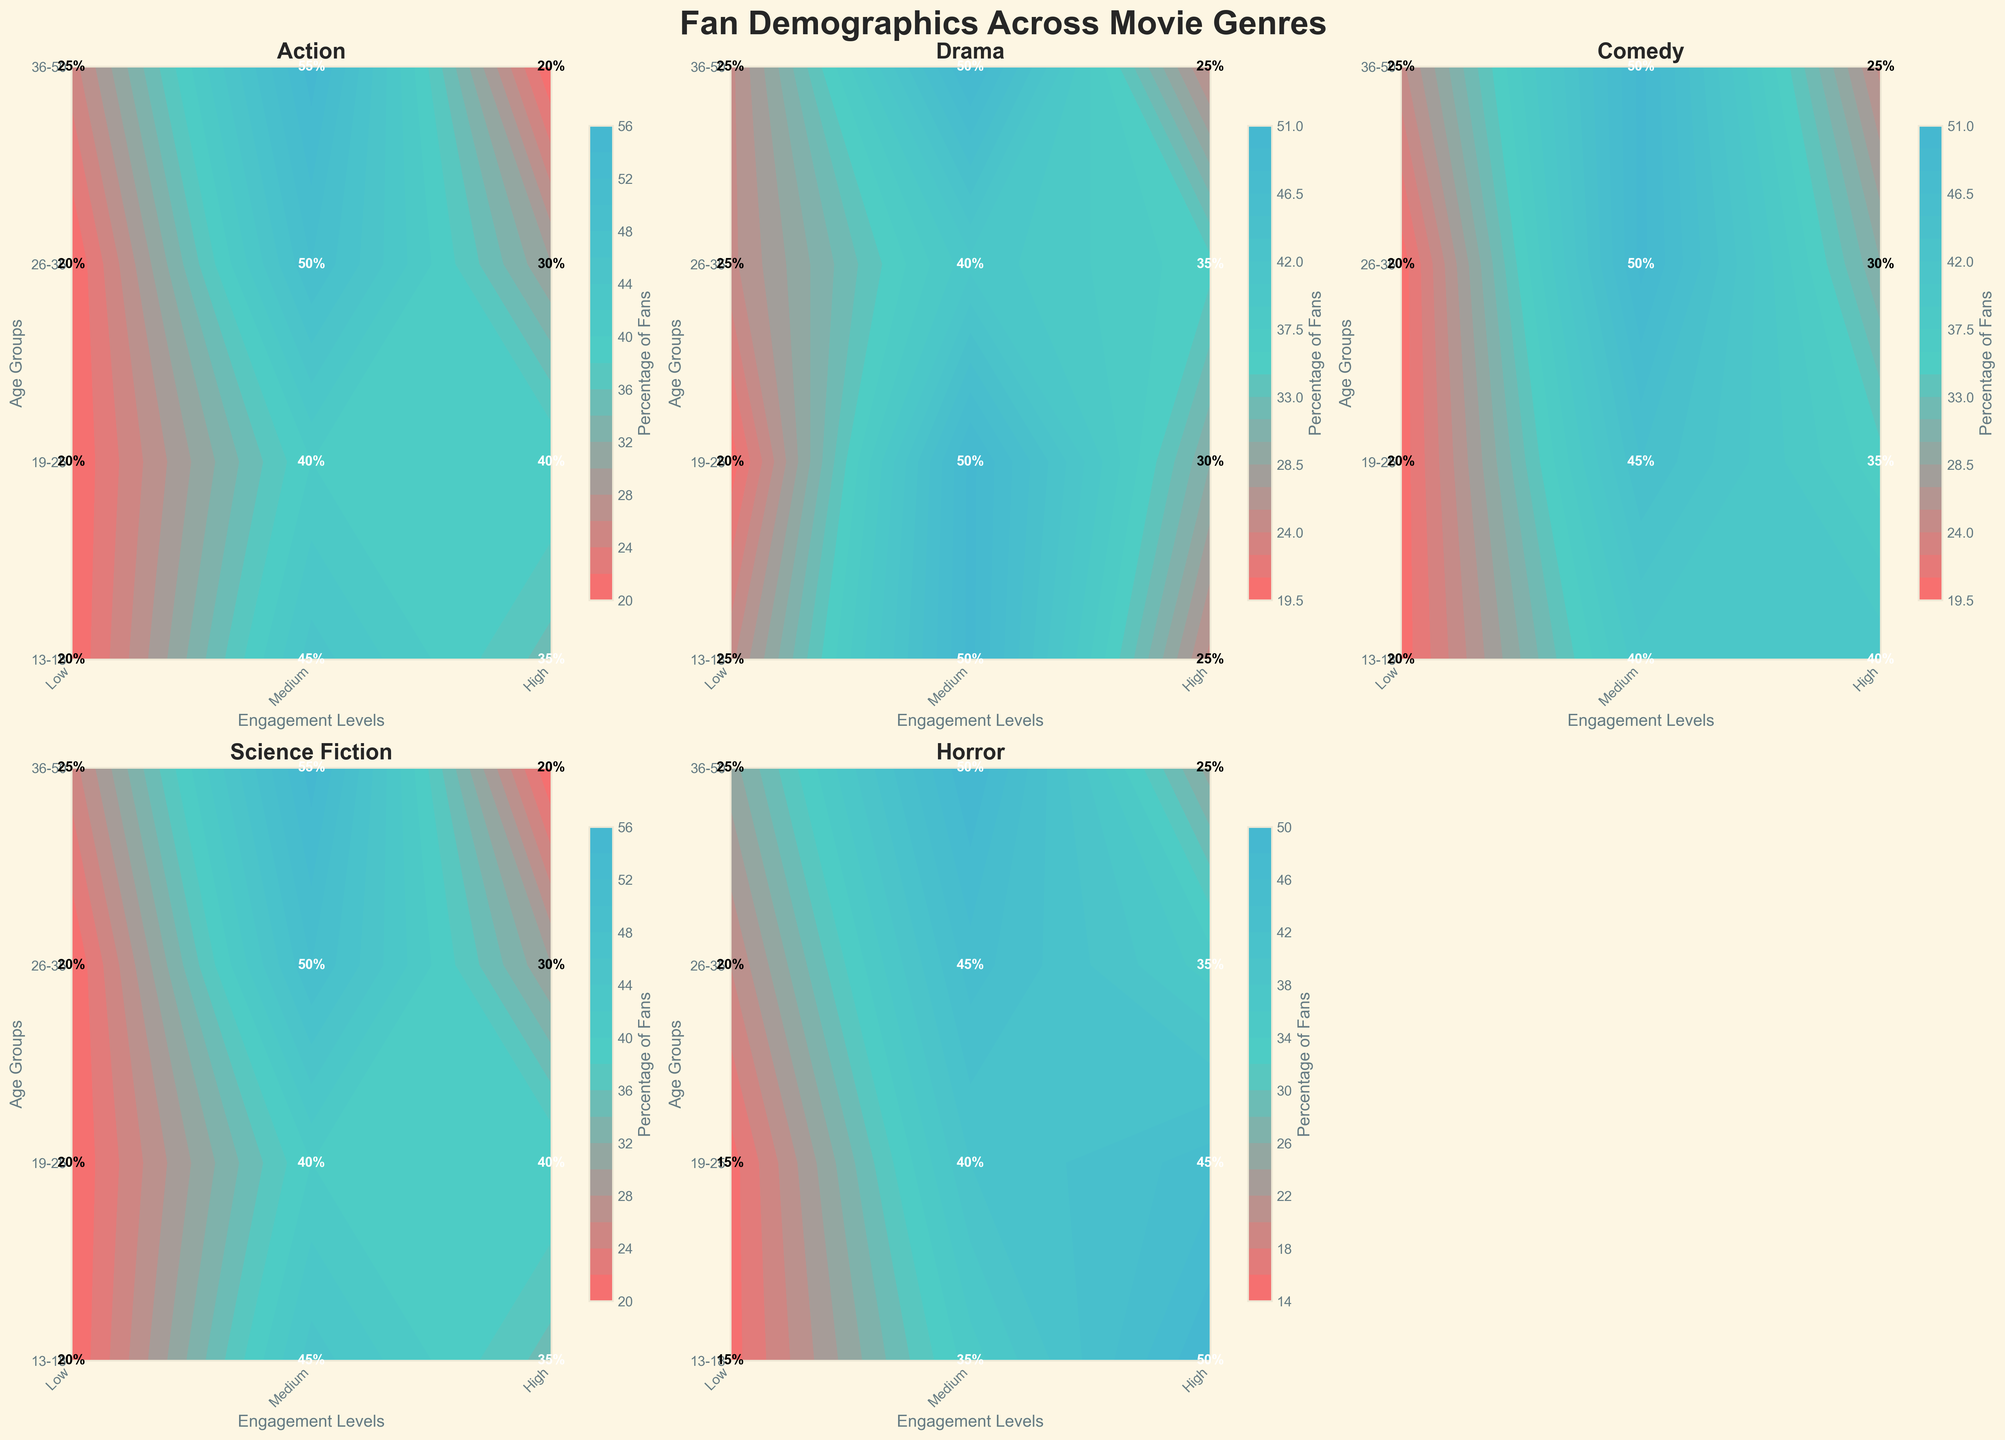What genre has the highest percentage of high engagement levels in the 13-18 age group? The figure shows the highest percentage of high engagement levels in the 13-18 age group for Horror at 50%. By visually scanning the contours and labels, Horror stands out as the highest.
Answer: Horror Which genre has the highest overall engagement levels for the 36-50 age group? By examining the contours for the 36-50 age group across all genres, we see that Science Fiction has the highest engagement level overall, indicated by Medium engagement levels at 55%, which is greater than other genres.
Answer: Science Fiction For the Drama genre, how does the proportion of fans with Medium engagement in the 19-25 age group compare to those with High engagement? In the Drama genre, the percentage of fans with Medium engagement in the 19-25 age group is 50%, whereas those with High engagement are 30%. So, Medium engagement has a higher proportion by 20%.
Answer: Medium engagement is 20% higher Does Comedy or Action have a higher proportion of low engagement fans in the 26-35 age group? For the 26-35 age group, both Comedy and Action show a 20% proportion of low engagement fans. Thus, they are equal in this regard.
Answer: They are equal In Science Fiction, what is the trend of high engagement levels from the 13-18 age group to the 36-50 age group? Looking at the contour plot for Science Fiction, high engagement levels are 35% in the 13-18 age group, 40% in the 19-25 age group, 30% in the 26-35 age group, and 20% in the 36-50 age group. Therefore, there is a decreasing trend from 40% down to 20% as age increases.
Answer: Decreasing trend What is the most engaged age group for Action movies, and what are their engagement percentages? For Action movies, the 19-25 age group has the highest percentage of engagement: 40% High, and 40% Medium, which collectively indicate a high engagement level.
Answer: 19-25 with 40% High and 40% Medium How do high engagement levels of Horror movies compare between the 13-18 and the 26-35 age groups? In Horror movies, the high engagement levels are 50% for the 13-18 age group and 35% for the 26-35 age group. This indicates a decrease of 15% from the younger to the older age group.
Answer: 15% decrease For Comedy, which engagement level is consistent across all age groups? The contour plot for Comedy shows that the Low engagement level is consistently 20% across all age groups (13-18, 19-25, 26-35, 36-50).
Answer: Low engagement What age group in Drama has the least amount of low engagement fans? For Drama, the 19-25 age group has the least amount of low engagement fans at 20%, as shown by the contour plot.
Answer: 19-25 age group Compare the percentage of Medium engagement fans of Science Fiction in the 36-50 age group with that of High engagement in the 13-18 age group. In the Science Fiction genre, the Medium engagement for the 36-50 age group is 55%, and the High engagement for the 13-18 age group is 35%. Thus, the Medium engagement in 36-50 is 20% higher than the High engagement in 13-18.
Answer: Medium engagement is 20% higher 